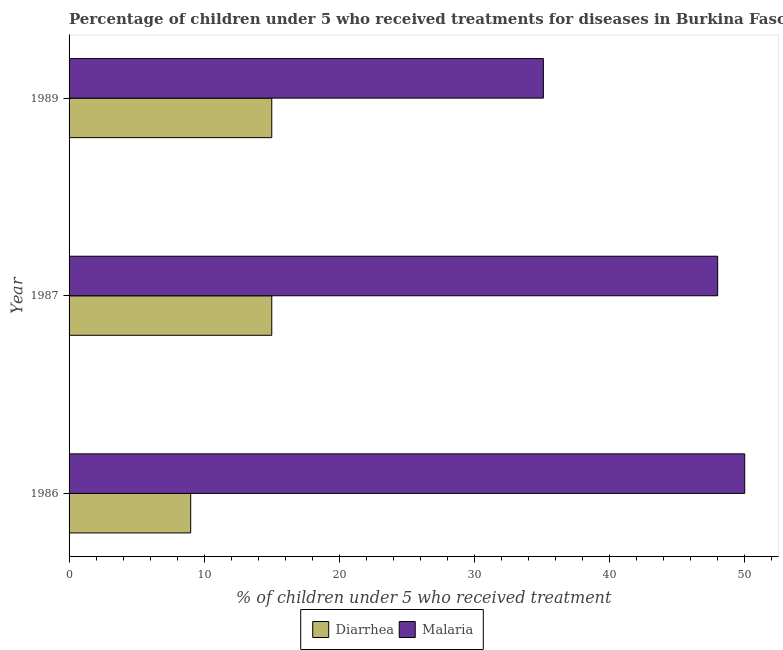How many groups of bars are there?
Provide a short and direct response. 3. Are the number of bars per tick equal to the number of legend labels?
Keep it short and to the point. Yes. Are the number of bars on each tick of the Y-axis equal?
Your response must be concise. Yes. How many bars are there on the 1st tick from the bottom?
Offer a terse response. 2. What is the percentage of children who received treatment for diarrhoea in 1987?
Provide a succinct answer. 15. Across all years, what is the maximum percentage of children who received treatment for malaria?
Your response must be concise. 50. Across all years, what is the minimum percentage of children who received treatment for malaria?
Offer a terse response. 35.1. In which year was the percentage of children who received treatment for diarrhoea minimum?
Your answer should be very brief. 1986. What is the total percentage of children who received treatment for diarrhoea in the graph?
Offer a very short reply. 39. What is the difference between the percentage of children who received treatment for malaria in 1986 and the percentage of children who received treatment for diarrhoea in 1989?
Your answer should be very brief. 35. What is the average percentage of children who received treatment for diarrhoea per year?
Your answer should be compact. 13. In the year 1986, what is the difference between the percentage of children who received treatment for diarrhoea and percentage of children who received treatment for malaria?
Keep it short and to the point. -41. What is the ratio of the percentage of children who received treatment for diarrhoea in 1986 to that in 1987?
Keep it short and to the point. 0.6. Is the difference between the percentage of children who received treatment for diarrhoea in 1987 and 1989 greater than the difference between the percentage of children who received treatment for malaria in 1987 and 1989?
Ensure brevity in your answer.  No. In how many years, is the percentage of children who received treatment for diarrhoea greater than the average percentage of children who received treatment for diarrhoea taken over all years?
Offer a very short reply. 2. Is the sum of the percentage of children who received treatment for diarrhoea in 1986 and 1987 greater than the maximum percentage of children who received treatment for malaria across all years?
Offer a terse response. No. What does the 2nd bar from the top in 1986 represents?
Offer a terse response. Diarrhea. What does the 2nd bar from the bottom in 1986 represents?
Your answer should be very brief. Malaria. How many years are there in the graph?
Offer a very short reply. 3. What is the difference between two consecutive major ticks on the X-axis?
Your response must be concise. 10. Are the values on the major ticks of X-axis written in scientific E-notation?
Keep it short and to the point. No. Does the graph contain grids?
Keep it short and to the point. No. How are the legend labels stacked?
Offer a terse response. Horizontal. What is the title of the graph?
Keep it short and to the point. Percentage of children under 5 who received treatments for diseases in Burkina Faso. What is the label or title of the X-axis?
Give a very brief answer. % of children under 5 who received treatment. What is the % of children under 5 who received treatment in Diarrhea in 1986?
Keep it short and to the point. 9. What is the % of children under 5 who received treatment of Malaria in 1986?
Offer a terse response. 50. What is the % of children under 5 who received treatment in Diarrhea in 1987?
Offer a very short reply. 15. What is the % of children under 5 who received treatment in Diarrhea in 1989?
Your response must be concise. 15. What is the % of children under 5 who received treatment of Malaria in 1989?
Your answer should be compact. 35.1. Across all years, what is the maximum % of children under 5 who received treatment of Diarrhea?
Your answer should be compact. 15. Across all years, what is the maximum % of children under 5 who received treatment in Malaria?
Offer a terse response. 50. Across all years, what is the minimum % of children under 5 who received treatment in Diarrhea?
Ensure brevity in your answer.  9. Across all years, what is the minimum % of children under 5 who received treatment of Malaria?
Make the answer very short. 35.1. What is the total % of children under 5 who received treatment in Diarrhea in the graph?
Your answer should be compact. 39. What is the total % of children under 5 who received treatment of Malaria in the graph?
Provide a short and direct response. 133.1. What is the difference between the % of children under 5 who received treatment in Diarrhea in 1986 and that in 1987?
Your response must be concise. -6. What is the difference between the % of children under 5 who received treatment in Malaria in 1986 and that in 1989?
Your answer should be compact. 14.9. What is the difference between the % of children under 5 who received treatment of Diarrhea in 1987 and that in 1989?
Provide a short and direct response. 0. What is the difference between the % of children under 5 who received treatment in Diarrhea in 1986 and the % of children under 5 who received treatment in Malaria in 1987?
Provide a succinct answer. -39. What is the difference between the % of children under 5 who received treatment of Diarrhea in 1986 and the % of children under 5 who received treatment of Malaria in 1989?
Your answer should be compact. -26.1. What is the difference between the % of children under 5 who received treatment of Diarrhea in 1987 and the % of children under 5 who received treatment of Malaria in 1989?
Provide a short and direct response. -20.1. What is the average % of children under 5 who received treatment in Diarrhea per year?
Your answer should be compact. 13. What is the average % of children under 5 who received treatment of Malaria per year?
Offer a terse response. 44.37. In the year 1986, what is the difference between the % of children under 5 who received treatment of Diarrhea and % of children under 5 who received treatment of Malaria?
Keep it short and to the point. -41. In the year 1987, what is the difference between the % of children under 5 who received treatment of Diarrhea and % of children under 5 who received treatment of Malaria?
Your answer should be compact. -33. In the year 1989, what is the difference between the % of children under 5 who received treatment in Diarrhea and % of children under 5 who received treatment in Malaria?
Your response must be concise. -20.1. What is the ratio of the % of children under 5 who received treatment in Diarrhea in 1986 to that in 1987?
Give a very brief answer. 0.6. What is the ratio of the % of children under 5 who received treatment of Malaria in 1986 to that in 1987?
Offer a very short reply. 1.04. What is the ratio of the % of children under 5 who received treatment in Diarrhea in 1986 to that in 1989?
Provide a short and direct response. 0.6. What is the ratio of the % of children under 5 who received treatment in Malaria in 1986 to that in 1989?
Your answer should be compact. 1.42. What is the ratio of the % of children under 5 who received treatment in Malaria in 1987 to that in 1989?
Make the answer very short. 1.37. What is the difference between the highest and the second highest % of children under 5 who received treatment of Malaria?
Make the answer very short. 2. 